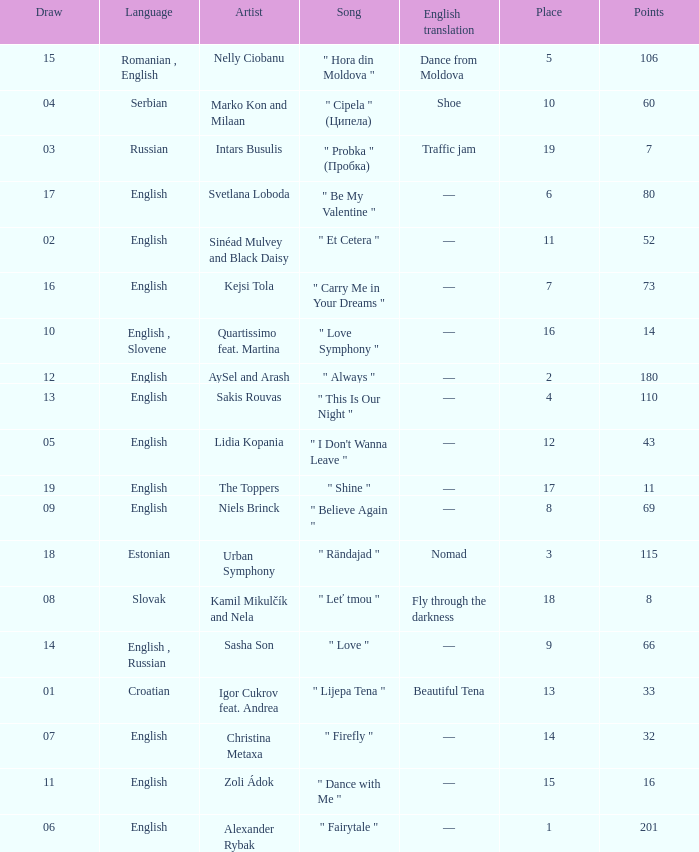Write the full table. {'header': ['Draw', 'Language', 'Artist', 'Song', 'English translation', 'Place', 'Points'], 'rows': [['15', 'Romanian , English', 'Nelly Ciobanu', '" Hora din Moldova "', 'Dance from Moldova', '5', '106'], ['04', 'Serbian', 'Marko Kon and Milaan', '" Cipela " (Ципела)', 'Shoe', '10', '60'], ['03', 'Russian', 'Intars Busulis', '" Probka " (Пробка)', 'Traffic jam', '19', '7'], ['17', 'English', 'Svetlana Loboda', '" Be My Valentine "', '—', '6', '80'], ['02', 'English', 'Sinéad Mulvey and Black Daisy', '" Et Cetera "', '—', '11', '52'], ['16', 'English', 'Kejsi Tola', '" Carry Me in Your Dreams "', '—', '7', '73'], ['10', 'English , Slovene', 'Quartissimo feat. Martina', '" Love Symphony "', '—', '16', '14'], ['12', 'English', 'AySel and Arash', '" Always "', '—', '2', '180'], ['13', 'English', 'Sakis Rouvas', '" This Is Our Night "', '—', '4', '110'], ['05', 'English', 'Lidia Kopania', '" I Don\'t Wanna Leave "', '—', '12', '43'], ['19', 'English', 'The Toppers', '" Shine "', '—', '17', '11'], ['09', 'English', 'Niels Brinck', '" Believe Again "', '—', '8', '69'], ['18', 'Estonian', 'Urban Symphony', '" Rändajad "', 'Nomad', '3', '115'], ['08', 'Slovak', 'Kamil Mikulčík and Nela', '" Leť tmou "', 'Fly through the darkness', '18', '8'], ['14', 'English , Russian', 'Sasha Son', '" Love "', '—', '9', '66'], ['01', 'Croatian', 'Igor Cukrov feat. Andrea', '" Lijepa Tena "', 'Beautiful Tena', '13', '33'], ['07', 'English', 'Christina Metaxa', '" Firefly "', '—', '14', '32'], ['11', 'English', 'Zoli Ádok', '" Dance with Me "', '—', '15', '16'], ['06', 'English', 'Alexander Rybak', '" Fairytale "', '—', '1', '201']]} What is the english translation when the language is english, draw is smaller than 16, and the artist is aysel and arash? —. 